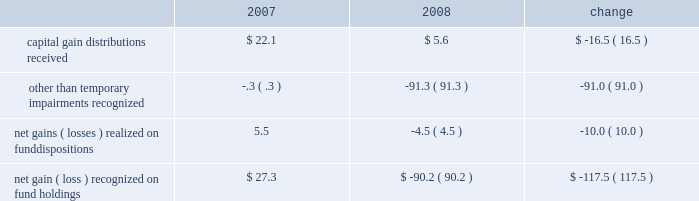Investment advisory revenues earned on the other investment portfolios that we manage decreased $ 3.6 million to $ 522.2 million .
Average assets in these portfolios were $ 142.1 billion during 2008 , up slightly from $ 141.4 billion in 2007 .
These minor changes , each less than 1% ( 1 % ) , are attributable to the timing of declining equity market valuations and cash flows among our separate account and sub-advised portfolios .
Net inflows , primarily from institutional investors , were $ 13.2 billion during 2008 , including the $ 1.3 billion transferred from the retirement funds to target-date trusts .
Decreases in market valuations , net of income , lowered our assets under management in these portfolios by $ 55.3 billion during 2008 .
Administrative fees increased $ 5.8 million to $ 353.9 million , primarily from increased costs of servicing activities for the mutual funds and their investors .
Changes in administrative fees are generally offset by similar changes in related operating expenses that are incurred to provide services to the funds and their investors .
Our largest expense , compensation and related costs , increased $ 18.4 million or 2.3% ( 2.3 % ) from 2007 .
This increase includes $ 37.2 million in salaries resulting from an 8.4% ( 8.4 % ) increase in our average staff count and an increase of our associates 2019 base salaries at the beginning of the year .
At december 31 , 2008 , we employed 5385 associates , up 6.0% ( 6.0 % ) from the end of 2007 , primarily to add capabilities and support increased volume-related activities and other growth over the past few years .
Over the course of 2008 , we slowed the growth of our associate base from earlier plans and the prior year .
We do not expect the number of our associates to increase in 2009 .
We also reduced our annual bonuses $ 27.6 million versus the 2007 year in response to recent and ongoing unfavorable financial market conditions that negatively impacted our operating results .
The balance of the increase is attributable to higher employee benefits and employment- related expenses , including an increase of $ 5.7 million in stock-based compensation .
Entering 2009 , we did not increase the salaries of our highest paid associates .
After higher spending during the first quarter of 2008 versus 2007 , investor sentiment in the uncertain and volatile market environment caused us to reduce advertising and promotion spending , which for the year was down $ 3.8 million from 2007 .
We expect to reduce these expenditures for 2009 versus 2008 , and estimate that spending in the first quarter of 2009 will be down about $ 5 million from the fourth quarter of 2008 .
We vary our level of spending based on market conditions and investor demand as well as our efforts to expand our investor base in the united states and abroad .
Occupancy and facility costs together with depreciation expense increased $ 18 million , or 12% ( 12 % ) compared to 2007 .
We have been expanding and renovating our facilities to accommodate the growth in our associates to meet business demands .
Other operating expenses were up $ 3.3 million from 2007 .
We increased our spending $ 9.8 million , primarily for professional fees and information and other third-party services .
Reductions in travel and charitable contributions partially offset these increases .
Our non-operating investment activity resulted in a net loss of $ 52.3 million in 2008 as compared to a net gain of $ 80.4 million in 2007 .
This change of $ 132.7 million is primarily attributable to losses recognized in 2008 on our investments in sponsored mutual funds , which resulted from declines in financial market values during the year. .
We recognized other than temporary impairments of our investments in sponsored mutual funds because of declines in fair value below cost for an extended period .
The significant declines in fair value below cost that occurred in 2008 were generally attributable to the adverse and ongoing market conditions discussed in the background section on page 18 of this report .
See also the discussion on page 24 of critical accounting policies for other than temporary impairments of available-for-sale securities .
In addition , income from money market and bond fund holdings was $ 19.3 million lower than in 2007 due to the significantly lower interest rate environment of 2008 .
Lower interest rates also led to substantial capital appreciation on our $ 40 million holding of u.s .
Treasury notes that we sold in december 2008 at a $ 2.6 million gain .
Management 2019s discussion & analysis 21 .
What was the total occupancy and facility costs together with depreciation expense in 2007 , in millions of dollars? 
Computations: (18 / 12%)
Answer: 150.0. 